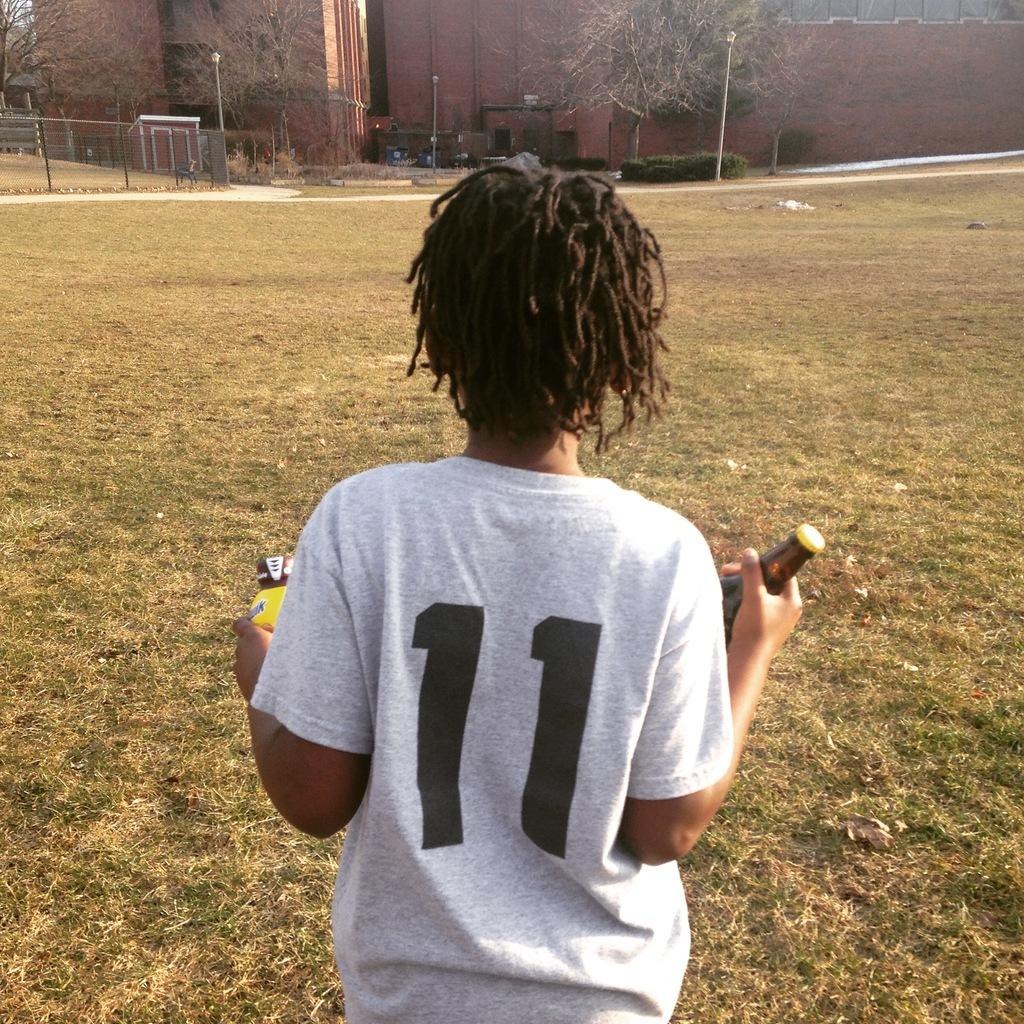<image>
Create a compact narrative representing the image presented. A person wearing a number 11 shirt is holding two beverages. 